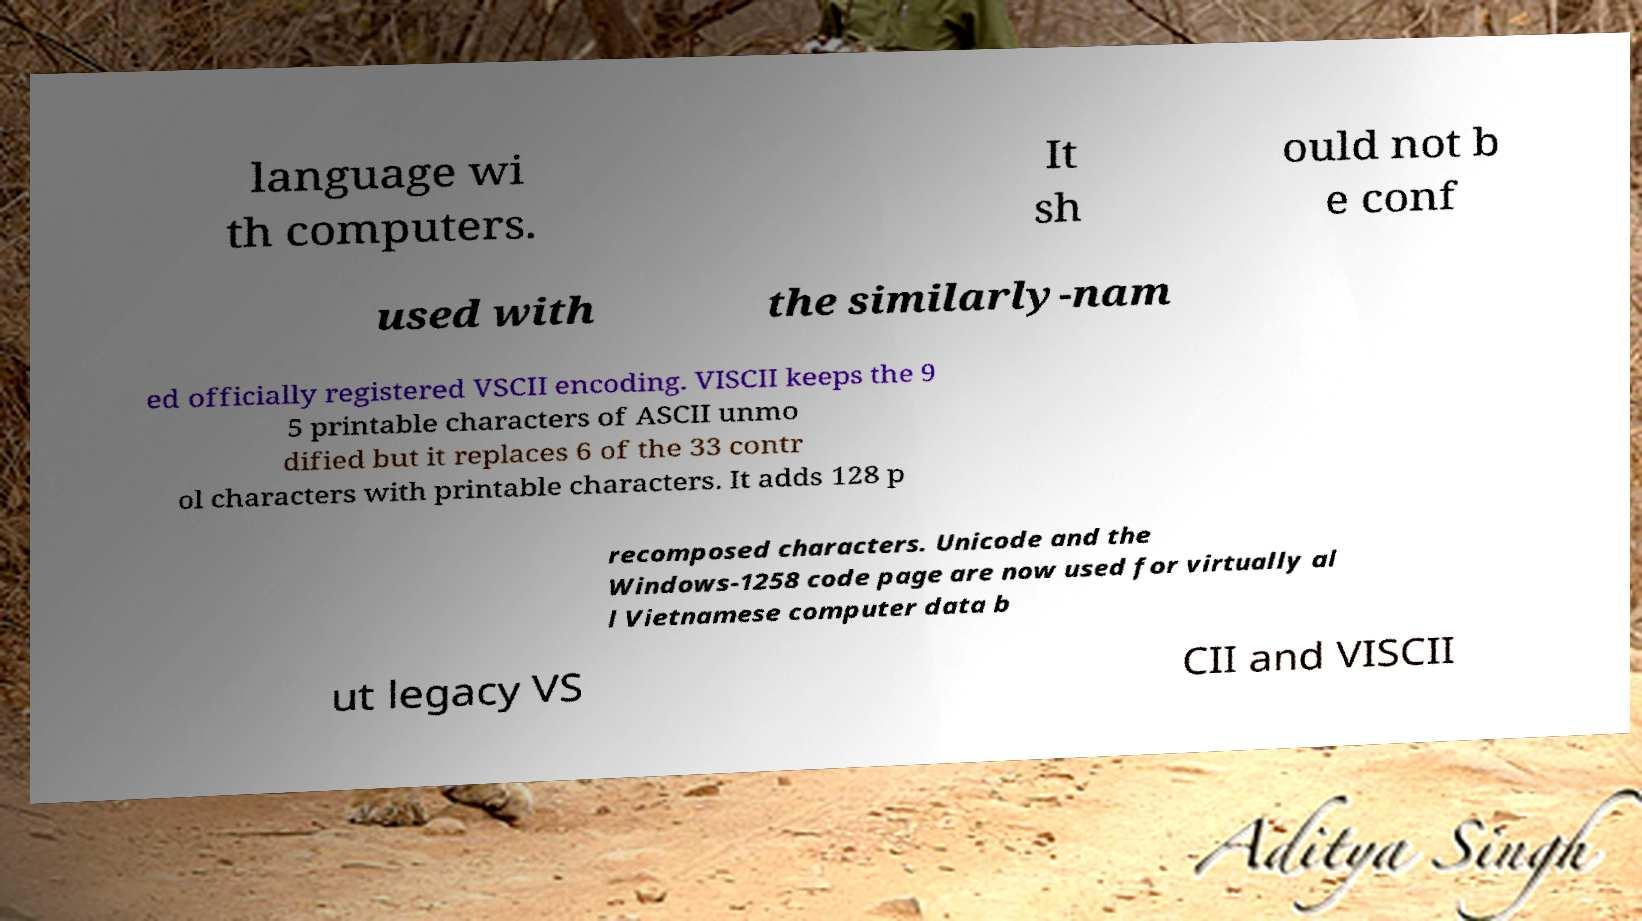What messages or text are displayed in this image? I need them in a readable, typed format. language wi th computers. It sh ould not b e conf used with the similarly-nam ed officially registered VSCII encoding. VISCII keeps the 9 5 printable characters of ASCII unmo dified but it replaces 6 of the 33 contr ol characters with printable characters. It adds 128 p recomposed characters. Unicode and the Windows-1258 code page are now used for virtually al l Vietnamese computer data b ut legacy VS CII and VISCII 